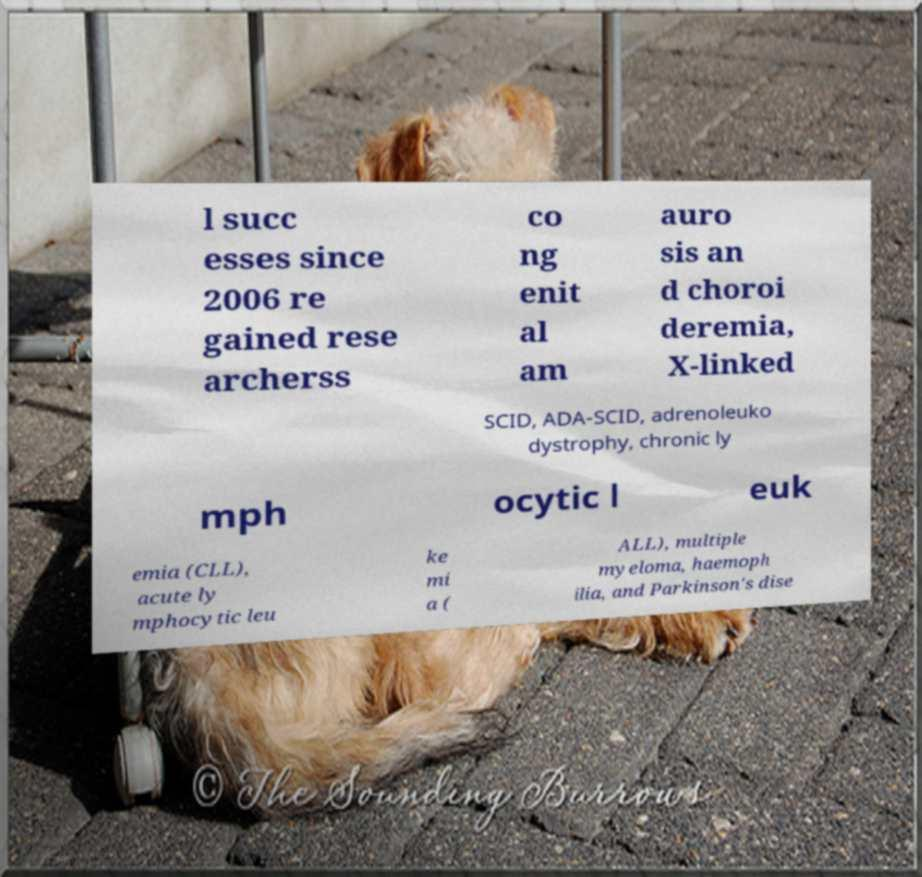Can you read and provide the text displayed in the image?This photo seems to have some interesting text. Can you extract and type it out for me? l succ esses since 2006 re gained rese archerss co ng enit al am auro sis an d choroi deremia, X-linked SCID, ADA-SCID, adrenoleuko dystrophy, chronic ly mph ocytic l euk emia (CLL), acute ly mphocytic leu ke mi a ( ALL), multiple myeloma, haemoph ilia, and Parkinson's dise 